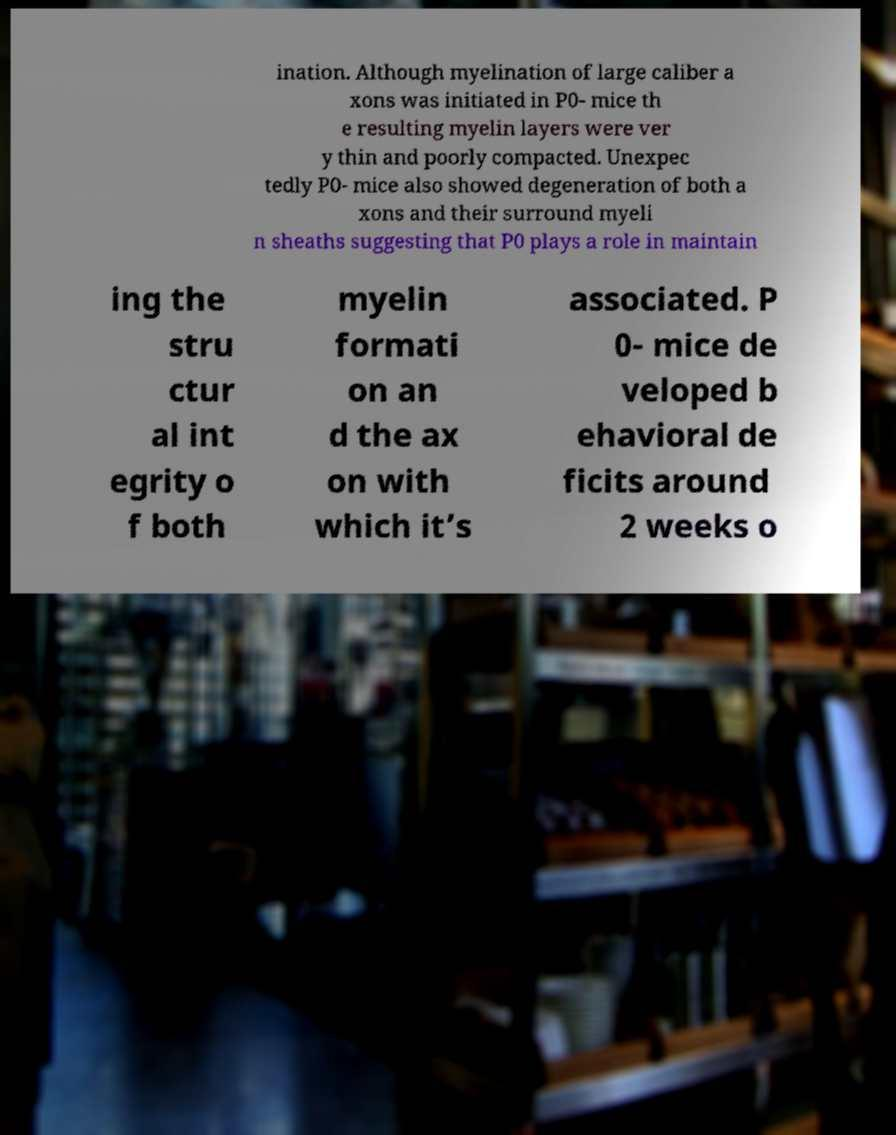I need the written content from this picture converted into text. Can you do that? ination. Although myelination of large caliber a xons was initiated in P0- mice th e resulting myelin layers were ver y thin and poorly compacted. Unexpec tedly P0- mice also showed degeneration of both a xons and their surround myeli n sheaths suggesting that P0 plays a role in maintain ing the stru ctur al int egrity o f both myelin formati on an d the ax on with which it’s associated. P 0- mice de veloped b ehavioral de ficits around 2 weeks o 